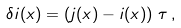Convert formula to latex. <formula><loc_0><loc_0><loc_500><loc_500>\delta i ( x ) = \left ( j ( x ) - i ( x ) \right ) \, \tau \, ,</formula> 